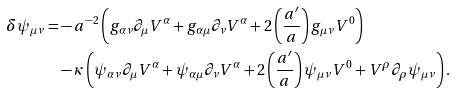<formula> <loc_0><loc_0><loc_500><loc_500>\delta \psi _ { \mu \nu } = & - a ^ { - 2 } \left ( g _ { \alpha \nu } \partial _ { \mu } V ^ { \alpha } + g _ { \alpha \mu } \partial _ { \nu } V ^ { \alpha } + 2 \left ( \frac { a ^ { \prime } } { a } \right ) g _ { \mu \nu } V ^ { 0 } \right ) \\ & - \kappa \left ( \psi _ { \alpha \nu } \partial _ { \mu } V ^ { \alpha } + \psi _ { \alpha \mu } \partial _ { \nu } V ^ { \alpha } + 2 \left ( \frac { a ^ { \prime } } { a } \right ) \psi _ { \mu \nu } V ^ { 0 } + V ^ { \rho } \partial _ { \rho } \psi _ { \mu \nu } \right ) .</formula> 